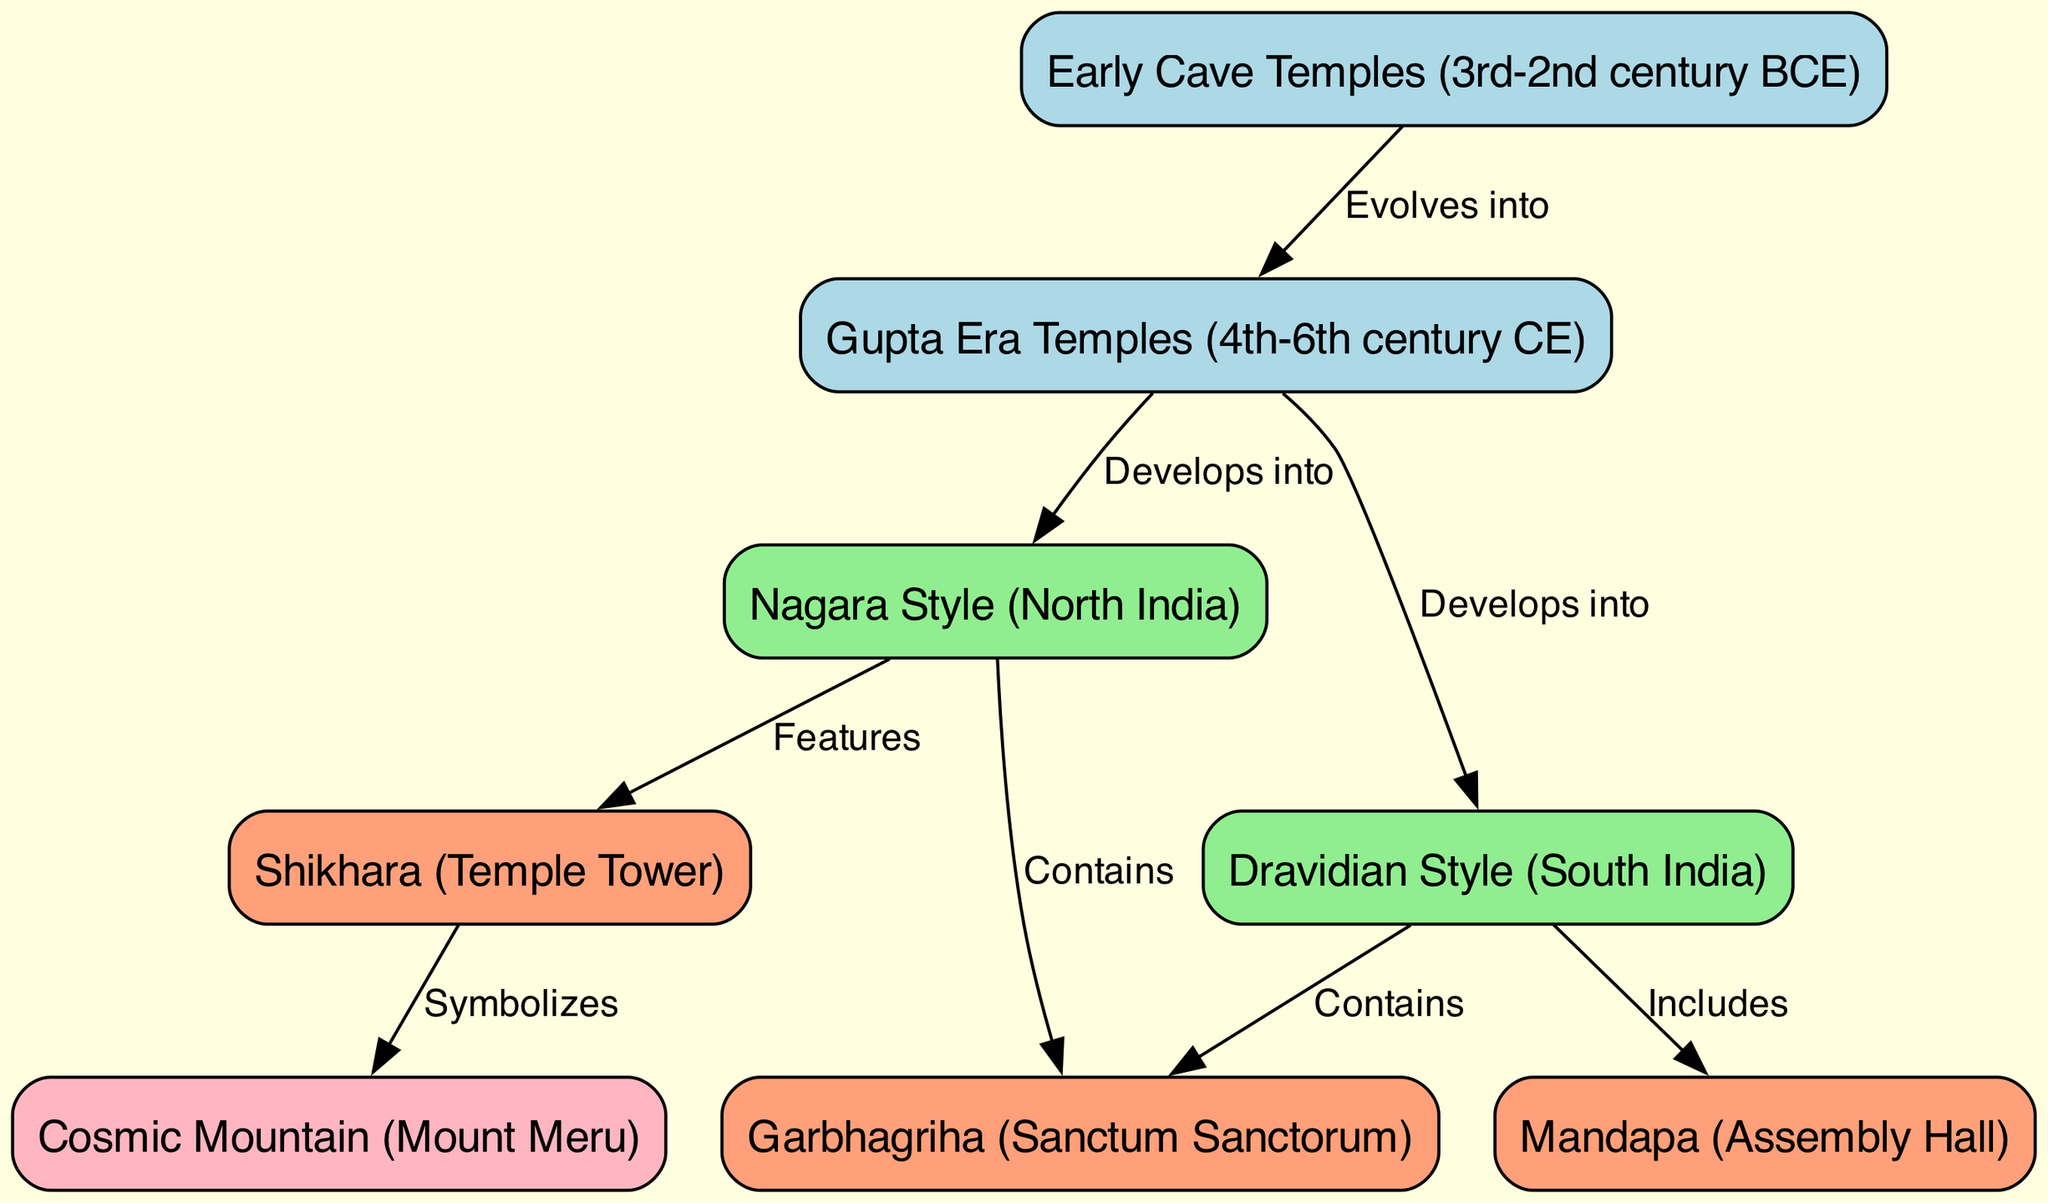What are the two styles of temple architecture developed from the Gupta Era Temples? The diagram shows that the Gupta Era Temples developed into two styles: Nagara Style (North India) and Dravidian Style (South India). These are indicated by the arrows pointing from node 2 to nodes 3 and 4, respectively.
Answer: Nagara Style and Dravidian Style How many nodes are labeled with temple components? The diagram contains three nodes labeled with temple components: Garbhagriha (Sanctum Sanctorum), Shikhara (Temple Tower), and Mandapa (Assembly Hall). We can count these nodes by identifying their labels in the diagram.
Answer: Three Which architectural feature symbolizes the Cosmic Mountain? The diagram indicates that the Shikhara (Temple Tower) symbolizes the Cosmic Mountain (Mount Meru), as reflected by the arrow leading from node 6 to node 8. The word 'Symbolizes' on the edge confirms this relationship.
Answer: Shikhara What is the relationship between Early Cave Temples and Gupta Era Temples? The relationship is indicated by the edge connecting node 1 (Early Cave Temples) to node 2 (Gupta Era Temples), labeled 'Evolves into.' This means that Early Cave Temples are a historical predecessor that transformed into Gupta Era Temples.
Answer: Evolves into In which centuries were Gupta Era Temples constructed? The diagram specifically notes that the Gupta Era Temples were constructed in the 4th to 6th century CE, which is directly stated in the label of node 2.
Answer: 4th-6th century CE 